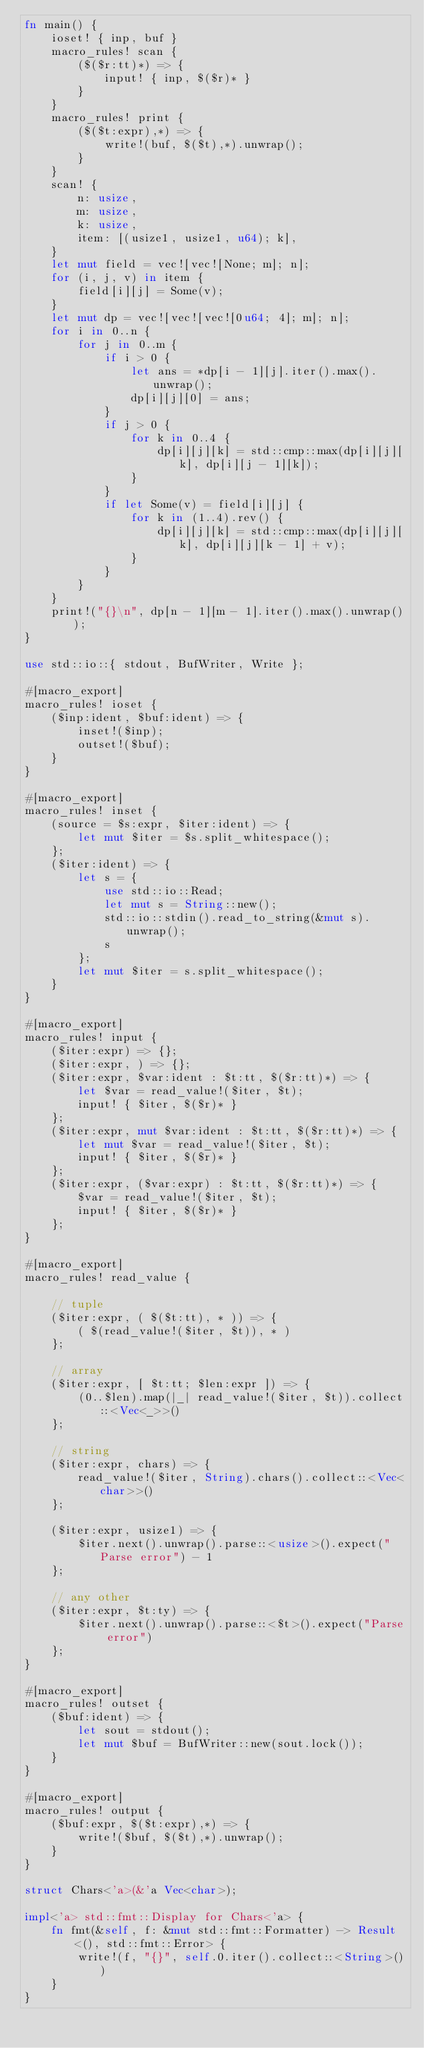<code> <loc_0><loc_0><loc_500><loc_500><_Rust_>fn main() {
    ioset! { inp, buf }
    macro_rules! scan {
        ($($r:tt)*) => {
            input! { inp, $($r)* }
        }
    }
    macro_rules! print {
        ($($t:expr),*) => {
            write!(buf, $($t),*).unwrap();
        } 
    }
    scan! {
        n: usize,
        m: usize,
        k: usize,
        item: [(usize1, usize1, u64); k],
    }
    let mut field = vec![vec![None; m]; n];
    for (i, j, v) in item {
        field[i][j] = Some(v);
    }
    let mut dp = vec![vec![vec![0u64; 4]; m]; n];
    for i in 0..n {
        for j in 0..m {
            if i > 0 {
                let ans = *dp[i - 1][j].iter().max().unwrap();
                dp[i][j][0] = ans;
            }
            if j > 0 {
                for k in 0..4 {
                    dp[i][j][k] = std::cmp::max(dp[i][j][k], dp[i][j - 1][k]);
                }
            }
            if let Some(v) = field[i][j] {
                for k in (1..4).rev() {
                    dp[i][j][k] = std::cmp::max(dp[i][j][k], dp[i][j][k - 1] + v);
                }
            }
        }
    }
    print!("{}\n", dp[n - 1][m - 1].iter().max().unwrap());
}

use std::io::{ stdout, BufWriter, Write };

#[macro_export]
macro_rules! ioset {
    ($inp:ident, $buf:ident) => {
        inset!($inp);
        outset!($buf);
    }
}

#[macro_export]
macro_rules! inset {
    (source = $s:expr, $iter:ident) => {
        let mut $iter = $s.split_whitespace();
    };
    ($iter:ident) => {
        let s = {
            use std::io::Read;
            let mut s = String::new();
            std::io::stdin().read_to_string(&mut s).unwrap();
            s
        };
        let mut $iter = s.split_whitespace();
    }
}

#[macro_export]
macro_rules! input {
    ($iter:expr) => {};
    ($iter:expr, ) => {};
    ($iter:expr, $var:ident : $t:tt, $($r:tt)*) => {
        let $var = read_value!($iter, $t);
        input! { $iter, $($r)* }
    };
    ($iter:expr, mut $var:ident : $t:tt, $($r:tt)*) => {
        let mut $var = read_value!($iter, $t);
        input! { $iter, $($r)* }
    };
    ($iter:expr, ($var:expr) : $t:tt, $($r:tt)*) => {
        $var = read_value!($iter, $t);
        input! { $iter, $($r)* }
    };
}

#[macro_export]
macro_rules! read_value {

    // tuple
    ($iter:expr, ( $($t:tt), * )) => {
        ( $(read_value!($iter, $t)), * )
    };
    
    // array
    ($iter:expr, [ $t:tt; $len:expr ]) => {
        (0..$len).map(|_| read_value!($iter, $t)).collect::<Vec<_>>()
    };
    
    // string
    ($iter:expr, chars) => {
        read_value!($iter, String).chars().collect::<Vec<char>>()
    };

    ($iter:expr, usize1) => {
        $iter.next().unwrap().parse::<usize>().expect("Parse error") - 1
    };
    
    // any other
    ($iter:expr, $t:ty) => {
        $iter.next().unwrap().parse::<$t>().expect("Parse error")
    };
}

#[macro_export]
macro_rules! outset {
    ($buf:ident) => {
        let sout = stdout();
        let mut $buf = BufWriter::new(sout.lock());
    }
}

#[macro_export]
macro_rules! output {
    ($buf:expr, $($t:expr),*) => {
        write!($buf, $($t),*).unwrap();
    }
}

struct Chars<'a>(&'a Vec<char>);

impl<'a> std::fmt::Display for Chars<'a> {
    fn fmt(&self, f: &mut std::fmt::Formatter) -> Result<(), std::fmt::Error> {
        write!(f, "{}", self.0.iter().collect::<String>())
    }
}
</code> 